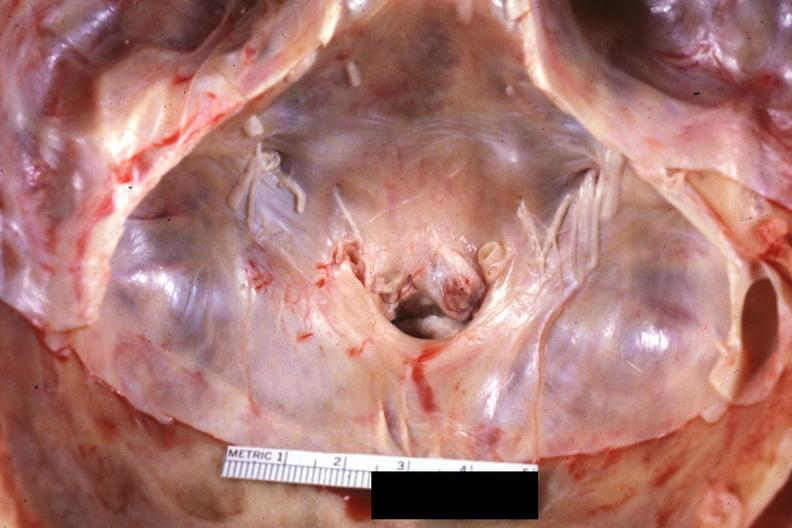why does this image show close-up of foramen magnum stenosis?
Answer the question using a single word or phrase. Due to subluxation atlas vertebra case 31 